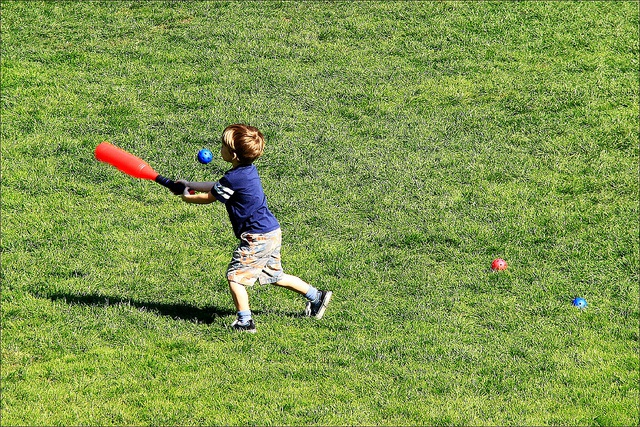Describe the objects in this image and their specific colors. I can see people in black, ivory, tan, and navy tones, baseball bat in black, red, and salmon tones, sports ball in black, blue, and lightblue tones, sports ball in black, salmon, lightpink, pink, and brown tones, and sports ball in black and lightblue tones in this image. 